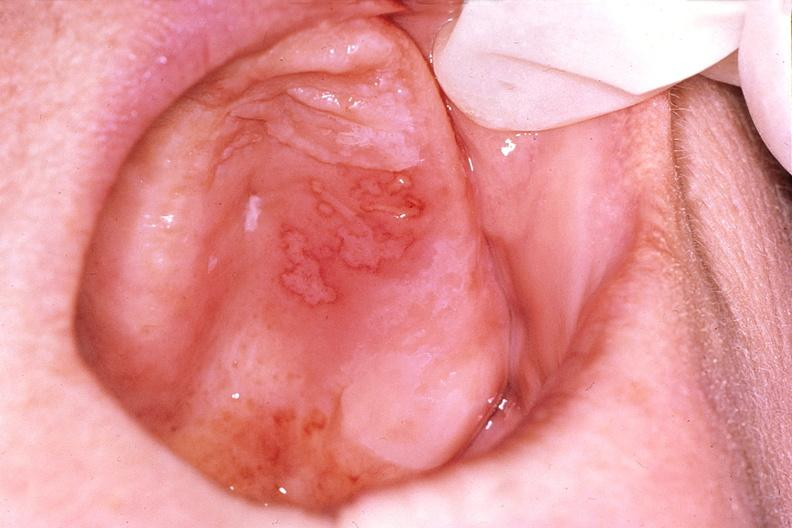where does this belong to?
Answer the question using a single word or phrase. Gastrointestinal system 